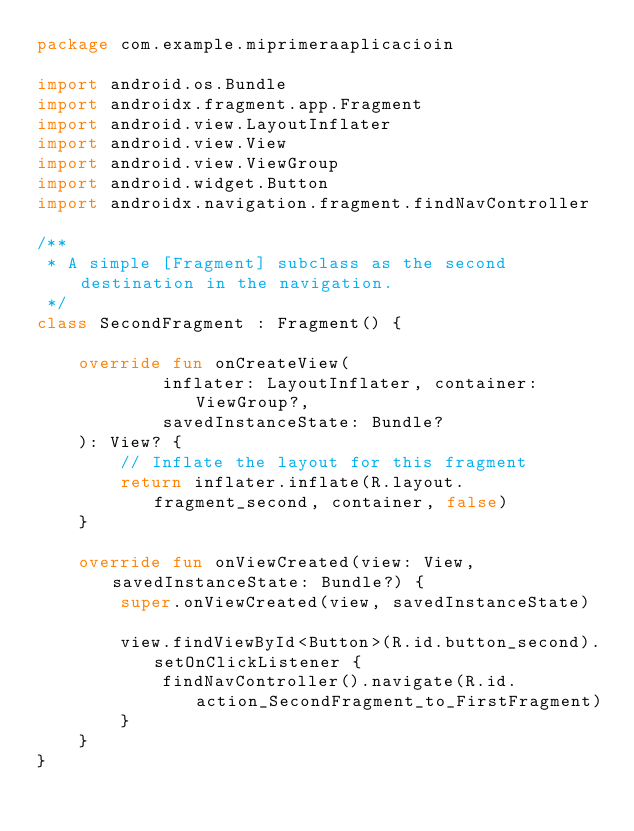<code> <loc_0><loc_0><loc_500><loc_500><_Kotlin_>package com.example.miprimeraaplicacioin

import android.os.Bundle
import androidx.fragment.app.Fragment
import android.view.LayoutInflater
import android.view.View
import android.view.ViewGroup
import android.widget.Button
import androidx.navigation.fragment.findNavController

/**
 * A simple [Fragment] subclass as the second destination in the navigation.
 */
class SecondFragment : Fragment() {

    override fun onCreateView(
            inflater: LayoutInflater, container: ViewGroup?,
            savedInstanceState: Bundle?
    ): View? {
        // Inflate the layout for this fragment
        return inflater.inflate(R.layout.fragment_second, container, false)
    }

    override fun onViewCreated(view: View, savedInstanceState: Bundle?) {
        super.onViewCreated(view, savedInstanceState)

        view.findViewById<Button>(R.id.button_second).setOnClickListener {
            findNavController().navigate(R.id.action_SecondFragment_to_FirstFragment)
        }
    }
}</code> 